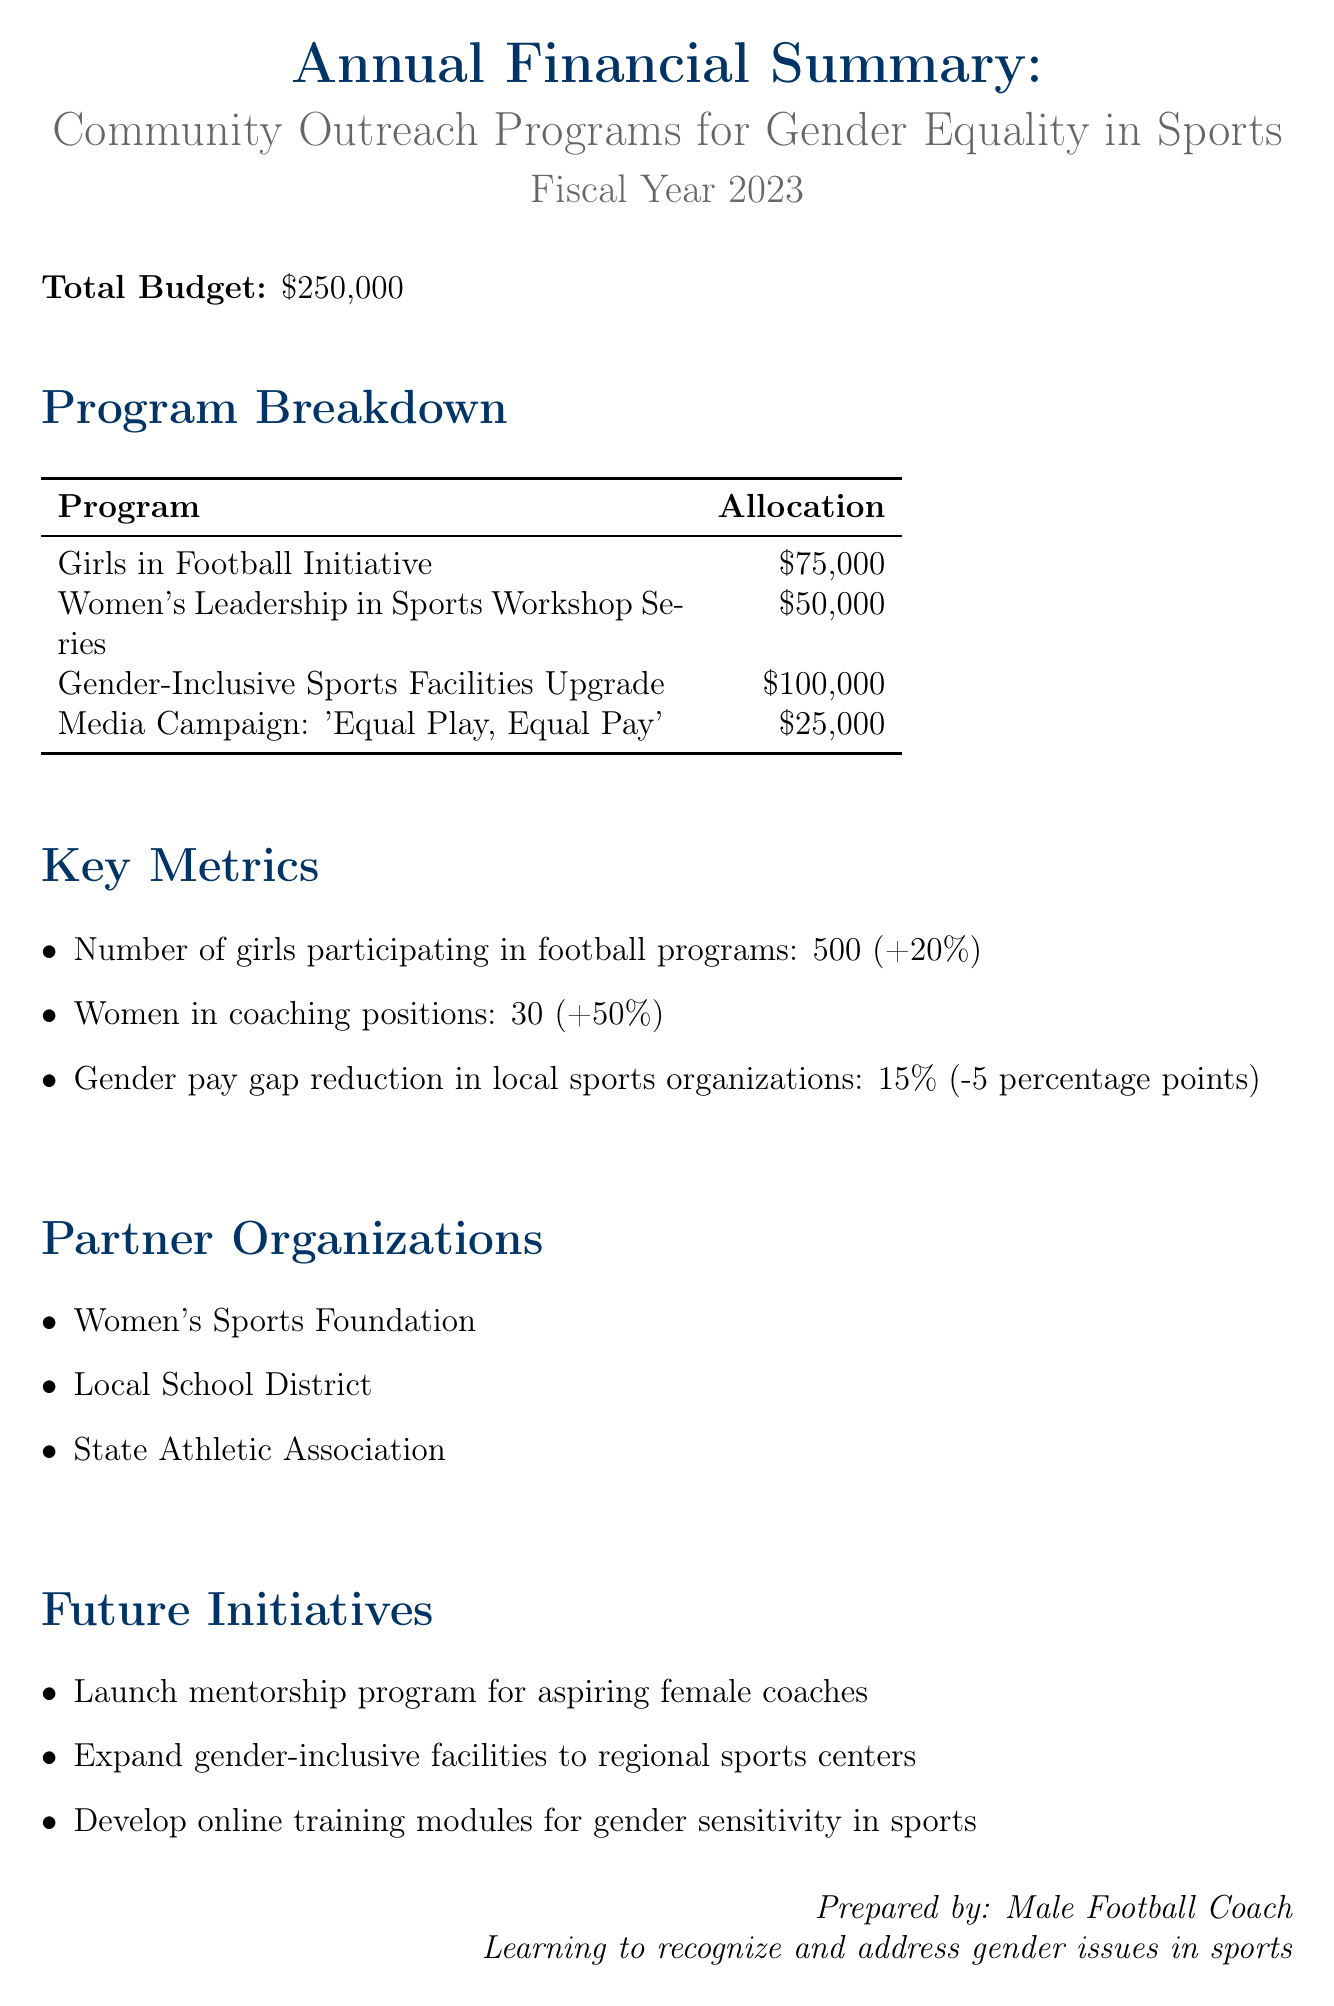what is the total budget for community outreach programs? The total budget is mentioned in the financial summary as \$250,000.
Answer: \$250,000 how much is allocated to the Gender-Inclusive Sports Facilities Upgrade? The allocation for the Gender-Inclusive Sports Facilities Upgrade is specified as \$100,000.
Answer: \$100,000 what percentage increase did the number of women in coaching positions experience? The document states that there was a +50% increase in women in coaching positions from the previous year.
Answer: +50% which organization is listed as a partner in the outreach programs? One of the partner organizations mentioned in the document is the Women's Sports Foundation.
Answer: Women's Sports Foundation what are the key activities under the Girls in Football Initiative? The key activities listed for the Girls in Football Initiative include Equipment donations, Coaching clinics, and School outreach programs.
Answer: Equipment donations, Coaching clinics, School outreach programs how many girls are participating in football programs as reported? The report indicates that there are 500 girls participating in football programs.
Answer: 500 what future initiative aims to support aspiring female coaches? The future initiative focused on supporting aspiring female coaches is the Launch mentorship program for aspiring female coaches.
Answer: Launch mentorship program for aspiring female coaches what is the value of the gender pay gap reduction in local sports organizations? The document reports a gender pay gap reduction of 15% in local sports organizations.
Answer: 15% what is the budget allocation for the Media Campaign: 'Equal Play, Equal Pay'? The budget allocation for the Media Campaign: 'Equal Play, Equal Pay' is stated as \$25,000.
Answer: \$25,000 